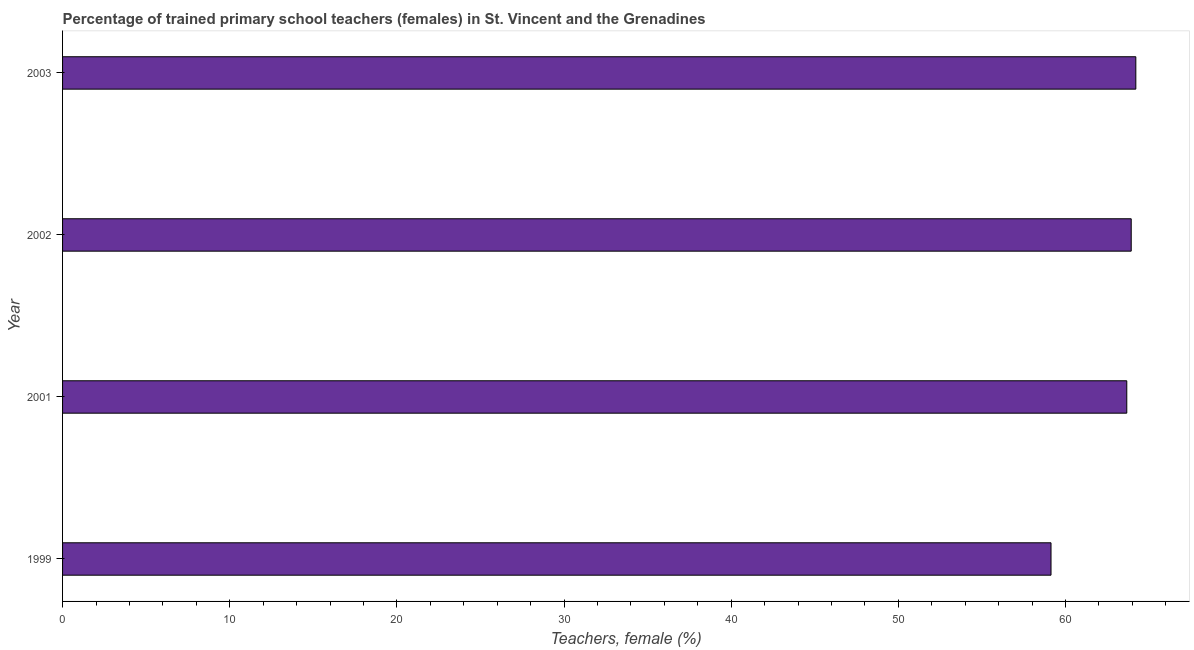Does the graph contain any zero values?
Provide a succinct answer. No. What is the title of the graph?
Your response must be concise. Percentage of trained primary school teachers (females) in St. Vincent and the Grenadines. What is the label or title of the X-axis?
Provide a succinct answer. Teachers, female (%). What is the percentage of trained female teachers in 1999?
Keep it short and to the point. 59.14. Across all years, what is the maximum percentage of trained female teachers?
Keep it short and to the point. 64.21. Across all years, what is the minimum percentage of trained female teachers?
Give a very brief answer. 59.14. What is the sum of the percentage of trained female teachers?
Make the answer very short. 250.95. What is the difference between the percentage of trained female teachers in 1999 and 2002?
Your response must be concise. -4.8. What is the average percentage of trained female teachers per year?
Make the answer very short. 62.74. What is the median percentage of trained female teachers?
Make the answer very short. 63.8. Do a majority of the years between 1999 and 2001 (inclusive) have percentage of trained female teachers greater than 42 %?
Keep it short and to the point. Yes. Is the difference between the percentage of trained female teachers in 2002 and 2003 greater than the difference between any two years?
Provide a succinct answer. No. What is the difference between the highest and the second highest percentage of trained female teachers?
Make the answer very short. 0.28. What is the difference between the highest and the lowest percentage of trained female teachers?
Give a very brief answer. 5.07. In how many years, is the percentage of trained female teachers greater than the average percentage of trained female teachers taken over all years?
Offer a very short reply. 3. How many bars are there?
Offer a terse response. 4. Are all the bars in the graph horizontal?
Your answer should be very brief. Yes. How many years are there in the graph?
Provide a succinct answer. 4. Are the values on the major ticks of X-axis written in scientific E-notation?
Give a very brief answer. No. What is the Teachers, female (%) of 1999?
Your response must be concise. 59.14. What is the Teachers, female (%) in 2001?
Keep it short and to the point. 63.67. What is the Teachers, female (%) in 2002?
Your answer should be very brief. 63.93. What is the Teachers, female (%) of 2003?
Ensure brevity in your answer.  64.21. What is the difference between the Teachers, female (%) in 1999 and 2001?
Ensure brevity in your answer.  -4.53. What is the difference between the Teachers, female (%) in 1999 and 2002?
Provide a succinct answer. -4.8. What is the difference between the Teachers, female (%) in 1999 and 2003?
Offer a very short reply. -5.07. What is the difference between the Teachers, female (%) in 2001 and 2002?
Ensure brevity in your answer.  -0.27. What is the difference between the Teachers, female (%) in 2001 and 2003?
Make the answer very short. -0.54. What is the difference between the Teachers, female (%) in 2002 and 2003?
Offer a terse response. -0.28. What is the ratio of the Teachers, female (%) in 1999 to that in 2001?
Provide a succinct answer. 0.93. What is the ratio of the Teachers, female (%) in 1999 to that in 2002?
Your answer should be compact. 0.93. What is the ratio of the Teachers, female (%) in 1999 to that in 2003?
Offer a very short reply. 0.92. 